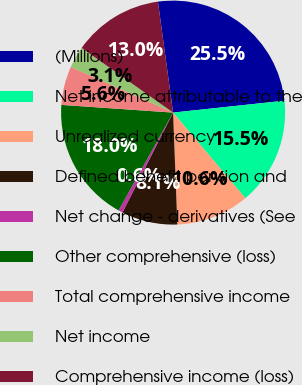Convert chart. <chart><loc_0><loc_0><loc_500><loc_500><pie_chart><fcel>(Millions)<fcel>Net income attributable to the<fcel>Unrealized currency<fcel>Defined benefit pension and<fcel>Net change - derivatives (See<fcel>Other comprehensive (loss)<fcel>Total comprehensive income<fcel>Net income<fcel>Comprehensive income (loss)<nl><fcel>25.47%<fcel>15.53%<fcel>10.56%<fcel>8.07%<fcel>0.62%<fcel>18.01%<fcel>5.59%<fcel>3.11%<fcel>13.04%<nl></chart> 